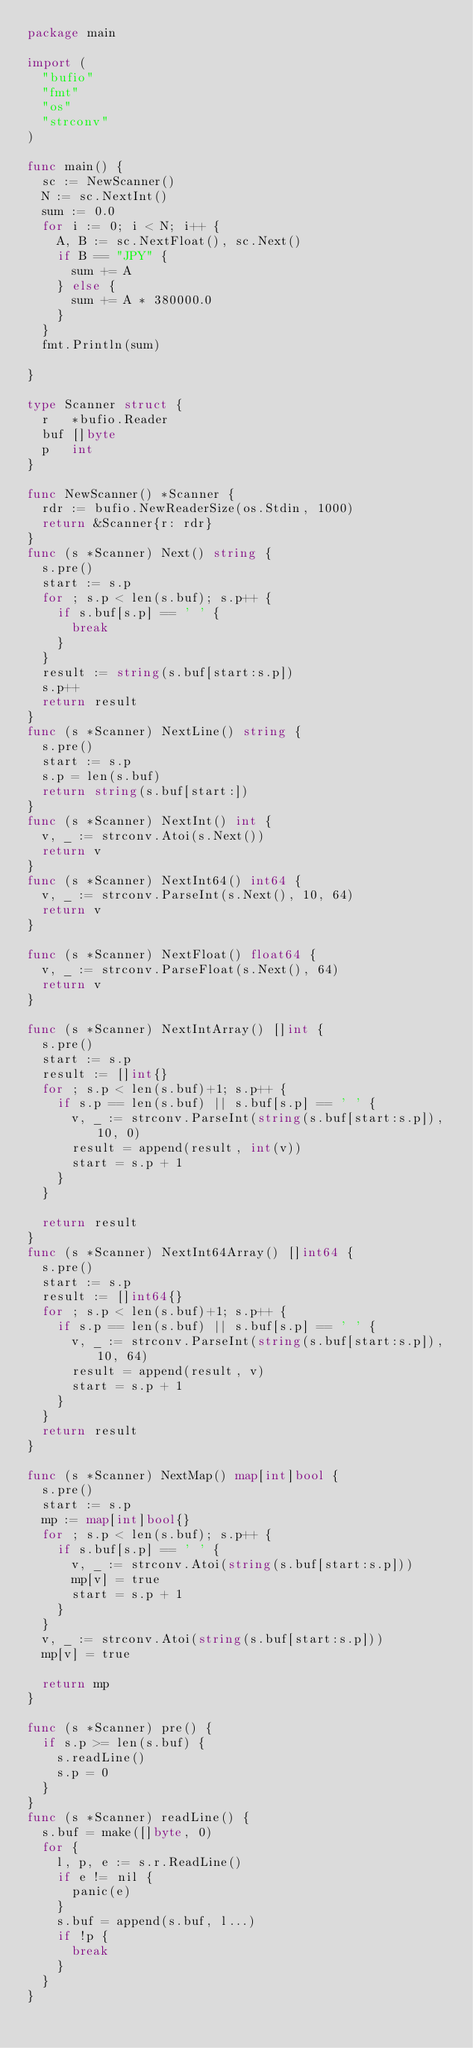<code> <loc_0><loc_0><loc_500><loc_500><_Go_>package main

import (
	"bufio"
	"fmt"
	"os"
	"strconv"
)

func main() {
	sc := NewScanner()
	N := sc.NextInt()
	sum := 0.0
	for i := 0; i < N; i++ {
		A, B := sc.NextFloat(), sc.Next()
		if B == "JPY" {
			sum += A
		} else {
			sum += A * 380000.0
		}
	}
	fmt.Println(sum)

}

type Scanner struct {
	r   *bufio.Reader
	buf []byte
	p   int
}

func NewScanner() *Scanner {
	rdr := bufio.NewReaderSize(os.Stdin, 1000)
	return &Scanner{r: rdr}
}
func (s *Scanner) Next() string {
	s.pre()
	start := s.p
	for ; s.p < len(s.buf); s.p++ {
		if s.buf[s.p] == ' ' {
			break
		}
	}
	result := string(s.buf[start:s.p])
	s.p++
	return result
}
func (s *Scanner) NextLine() string {
	s.pre()
	start := s.p
	s.p = len(s.buf)
	return string(s.buf[start:])
}
func (s *Scanner) NextInt() int {
	v, _ := strconv.Atoi(s.Next())
	return v
}
func (s *Scanner) NextInt64() int64 {
	v, _ := strconv.ParseInt(s.Next(), 10, 64)
	return v
}

func (s *Scanner) NextFloat() float64 {
	v, _ := strconv.ParseFloat(s.Next(), 64)
	return v
}

func (s *Scanner) NextIntArray() []int {
	s.pre()
	start := s.p
	result := []int{}
	for ; s.p < len(s.buf)+1; s.p++ {
		if s.p == len(s.buf) || s.buf[s.p] == ' ' {
			v, _ := strconv.ParseInt(string(s.buf[start:s.p]), 10, 0)
			result = append(result, int(v))
			start = s.p + 1
		}
	}

	return result
}
func (s *Scanner) NextInt64Array() []int64 {
	s.pre()
	start := s.p
	result := []int64{}
	for ; s.p < len(s.buf)+1; s.p++ {
		if s.p == len(s.buf) || s.buf[s.p] == ' ' {
			v, _ := strconv.ParseInt(string(s.buf[start:s.p]), 10, 64)
			result = append(result, v)
			start = s.p + 1
		}
	}
	return result
}

func (s *Scanner) NextMap() map[int]bool {
	s.pre()
	start := s.p
	mp := map[int]bool{}
	for ; s.p < len(s.buf); s.p++ {
		if s.buf[s.p] == ' ' {
			v, _ := strconv.Atoi(string(s.buf[start:s.p]))
			mp[v] = true
			start = s.p + 1
		}
	}
	v, _ := strconv.Atoi(string(s.buf[start:s.p]))
	mp[v] = true

	return mp
}

func (s *Scanner) pre() {
	if s.p >= len(s.buf) {
		s.readLine()
		s.p = 0
	}
}
func (s *Scanner) readLine() {
	s.buf = make([]byte, 0)
	for {
		l, p, e := s.r.ReadLine()
		if e != nil {
			panic(e)
		}
		s.buf = append(s.buf, l...)
		if !p {
			break
		}
	}
}
</code> 